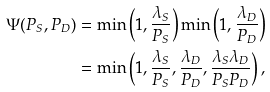<formula> <loc_0><loc_0><loc_500><loc_500>\Psi ( P _ { S } , P _ { D } ) & = \min \left ( 1 , \frac { \lambda _ { S } } { P _ { S } } \right ) \min \left ( 1 , \frac { \lambda _ { D } } { P _ { D } } \right ) \\ & = \min \left ( 1 , \frac { \lambda _ { S } } { P _ { S } } , \frac { \lambda _ { D } } { P _ { D } } , \frac { \lambda _ { S } \lambda _ { D } } { P _ { S } P _ { D } } \right ) ,</formula> 